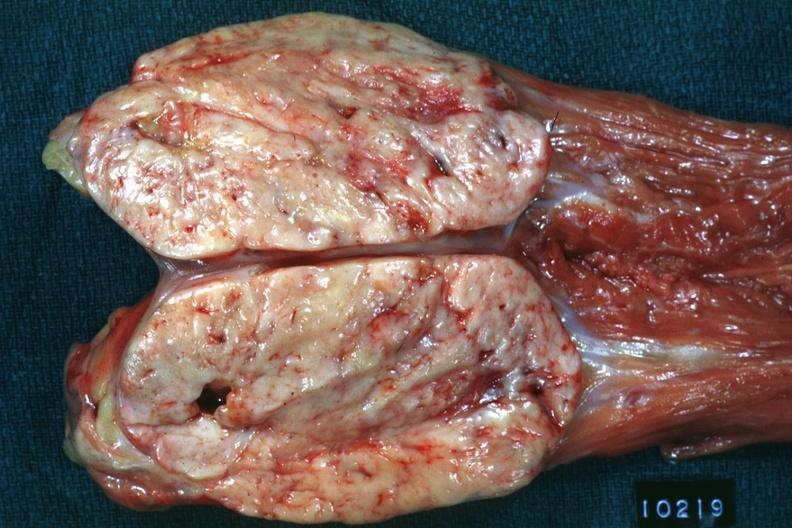how does opened muscle psoa color large ovoid typical sarcoma?
Answer the question using a single word or phrase. Natural 